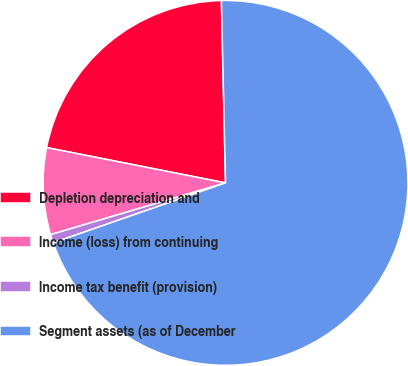Convert chart. <chart><loc_0><loc_0><loc_500><loc_500><pie_chart><fcel>Depletion depreciation and<fcel>Income (loss) from continuing<fcel>Income tax benefit (provision)<fcel>Segment assets (as of December<nl><fcel>21.54%<fcel>7.68%<fcel>0.75%<fcel>70.04%<nl></chart> 